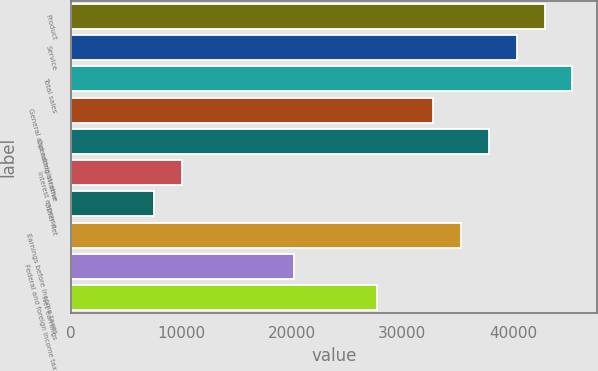<chart> <loc_0><loc_0><loc_500><loc_500><bar_chart><fcel>Product<fcel>Service<fcel>Total sales<fcel>General and administrative<fcel>Operating income<fcel>Interest expense<fcel>Other net<fcel>Earnings before income taxes<fcel>Federal and foreign income tax<fcel>Net earnings<nl><fcel>42865.2<fcel>40344.1<fcel>45386.2<fcel>32781.1<fcel>37823.1<fcel>10091.9<fcel>7570.87<fcel>35302.1<fcel>20176<fcel>27739<nl></chart> 